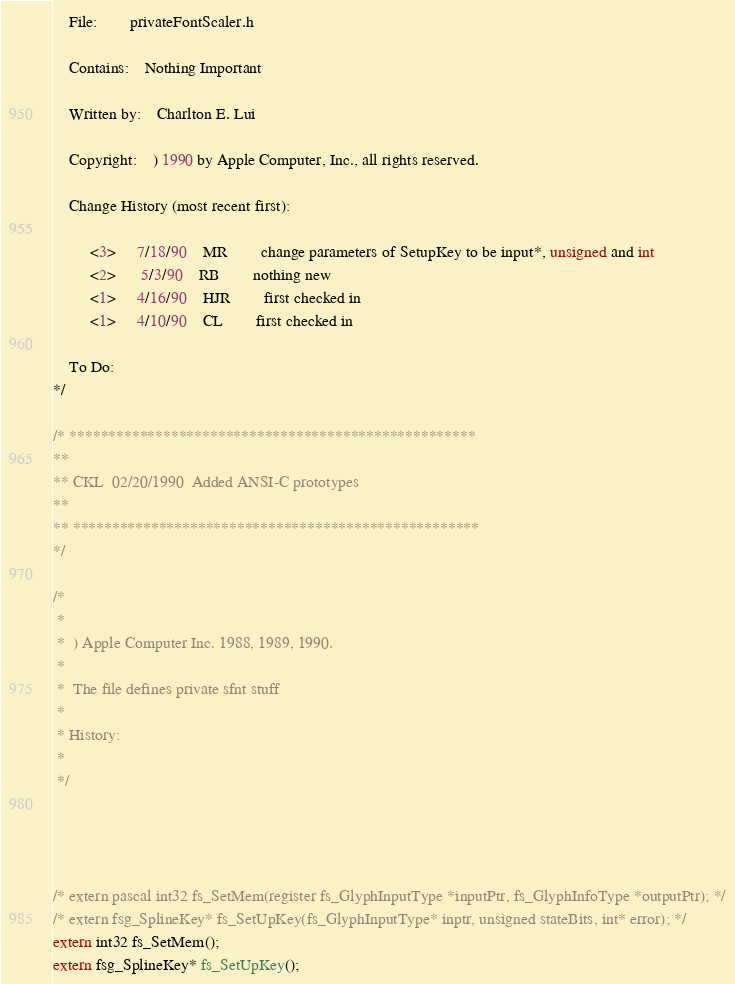<code> <loc_0><loc_0><loc_500><loc_500><_C_>	File:		privateFontScaler.h

	Contains:	Nothing Important

	Written by:	Charlton E. Lui

	Copyright:	) 1990 by Apple Computer, Inc., all rights reserved.

	Change History (most recent first):

		 <3>	 7/18/90	MR		change parameters of SetupKey to be input*, unsigned and int
		 <2>	  5/3/90	RB		nothing new
		 <1>	 4/16/90	HJR		first checked in
		 <1>	 4/10/90	CL		first checked in

	To Do:
*/

/* ****************************************************
**
** CKL	02/20/1990	Added ANSI-C prototypes
**
** ****************************************************
*/
 
/*
 *
 *  ) Apple Computer Inc. 1988, 1989, 1990.
 *
 *	The file defines private sfnt stuff
 *
 * History:
 * 
 */




/* extern pascal int32 fs_SetMem(register fs_GlyphInputType *inputPtr, fs_GlyphInfoType *outputPtr); */
/* extern fsg_SplineKey* fs_SetUpKey(fs_GlyphInputType* inptr, unsigned stateBits, int* error); */
extern int32 fs_SetMem();
extern fsg_SplineKey* fs_SetUpKey();

</code> 